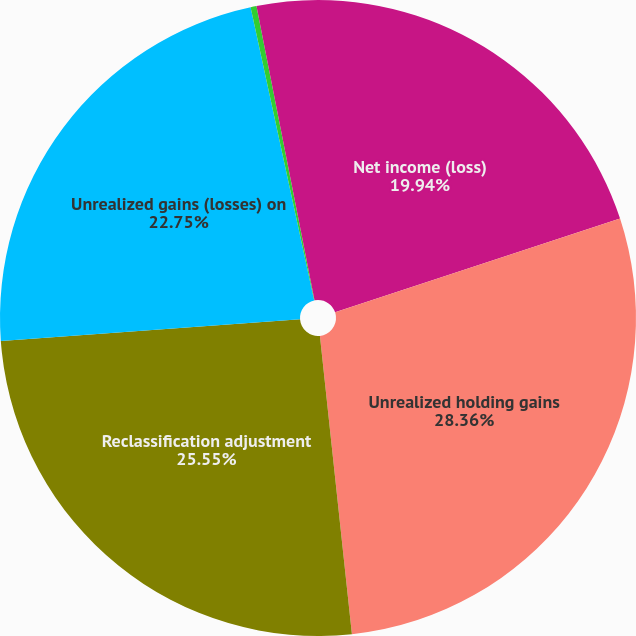<chart> <loc_0><loc_0><loc_500><loc_500><pie_chart><fcel>Net income (loss)<fcel>Unrealized holding gains<fcel>Reclassification adjustment<fcel>Unrealized gains (losses) on<fcel>Unrealized interest rate hedge<fcel>Unrealized foreign currency<nl><fcel>19.94%<fcel>28.36%<fcel>25.55%<fcel>22.75%<fcel>0.3%<fcel>3.1%<nl></chart> 